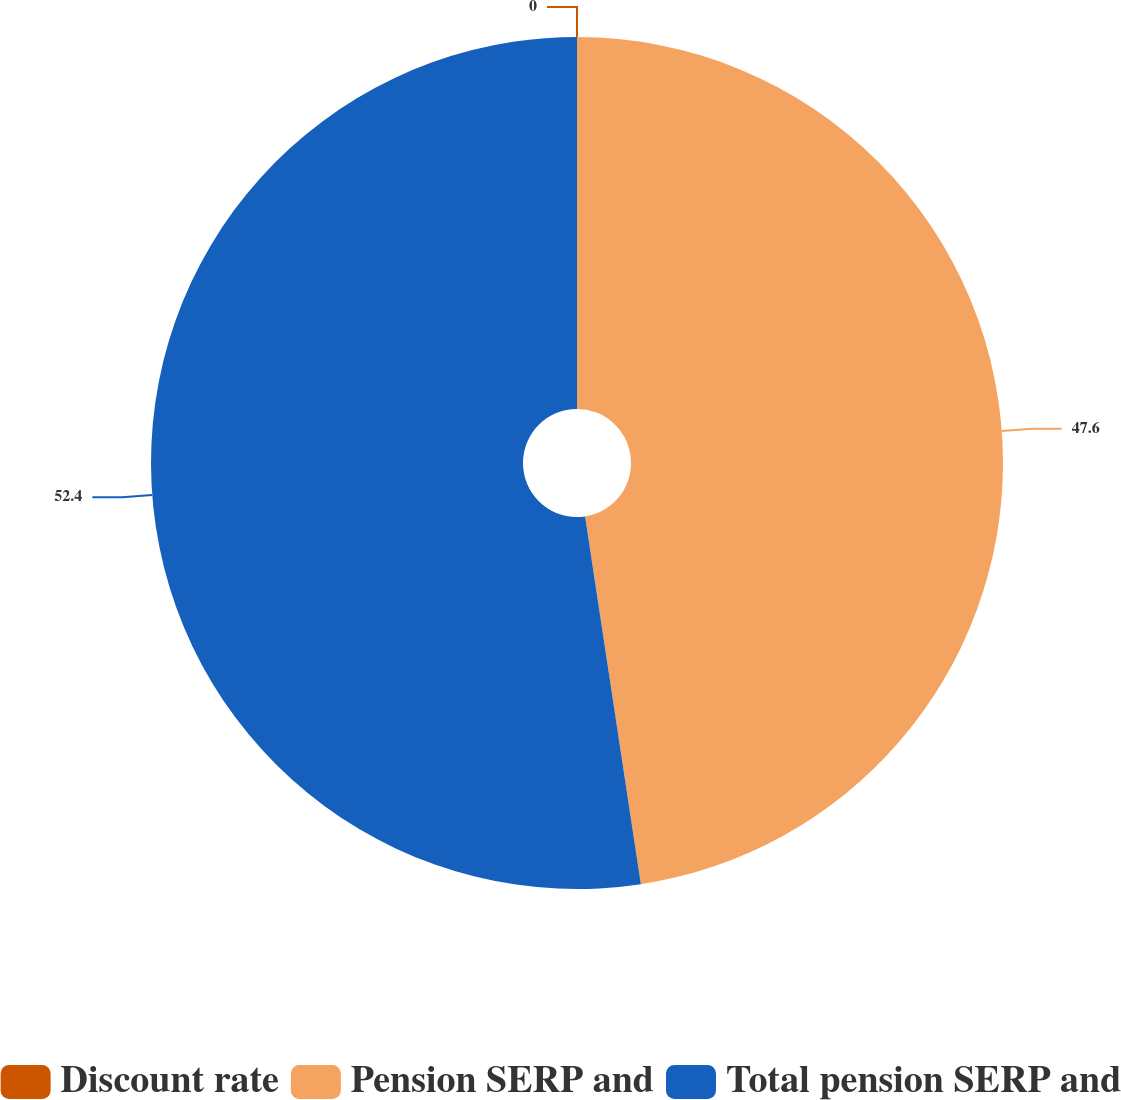<chart> <loc_0><loc_0><loc_500><loc_500><pie_chart><fcel>Discount rate<fcel>Pension SERP and<fcel>Total pension SERP and<nl><fcel>0.0%<fcel>47.6%<fcel>52.39%<nl></chart> 